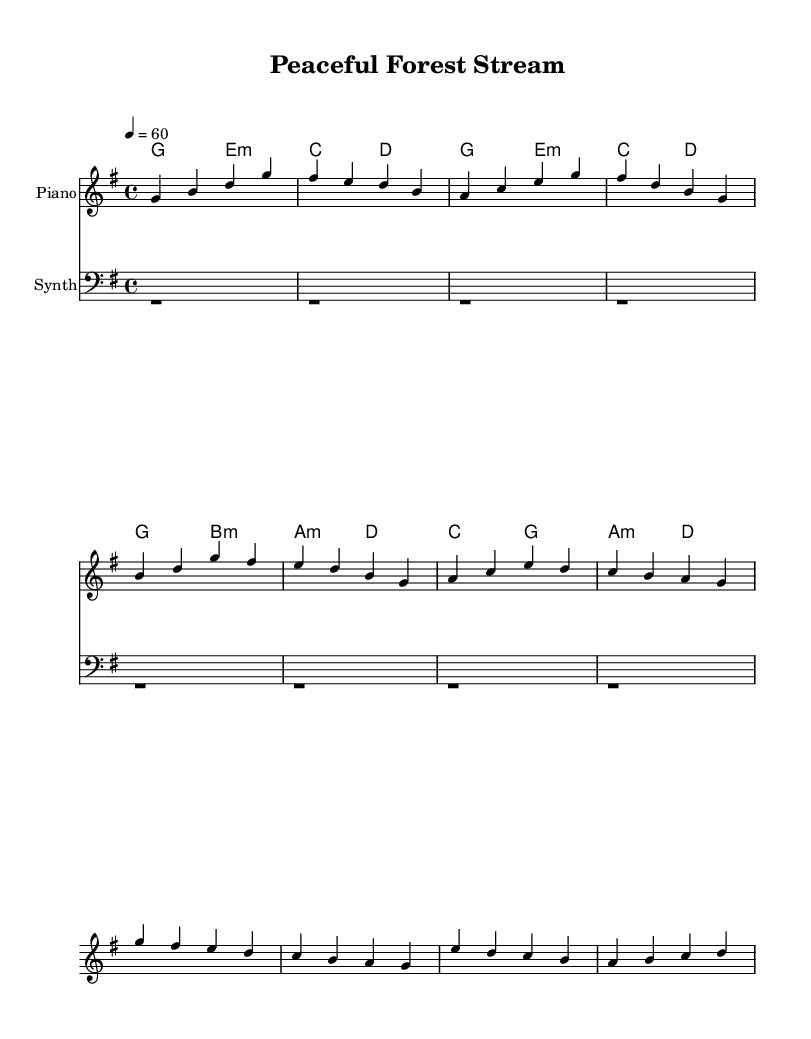What is the key signature of this music? The key signature indicated in the sheet music is G major, which has one sharp (F#). This can be identified by looking at the key signature notation at the beginning of the staff.
Answer: G major What is the time signature of this music? The time signature is 4/4, which is shown at the beginning of the score. This means there are four beats in each measure, and each quarter note is one beat.
Answer: 4/4 What is the tempo of this music? The tempo marking indicates a tempo of 60 beats per minute. This is specified at the start of the piece with the marking "4 = 60".
Answer: 60 How many measures are in the melody? By counting the measures in the provided melody sections (Intro, Verse, and Chorus), we find a total of 12 measures. Each line typically contains 4 measures, and there are 3 lines in total for the melody.
Answer: 12 What type of instruments are used in this arrangement? The arrangement includes a Piano and a Synth as indicated in the staff names. Each instrument is represented by its own staff, showing the separate roles they play in the piece.
Answer: Piano and Synth What is the structure of the melody in terms of sections? The melody consists of three sections: Intro, Verse, and Chorus. This can be determined by the labels used in the music and the different melodic lines provided.
Answer: Intro, Verse, Chorus What is the main harmonic progression used in this music? The harmonic progression consists mainly of the chords G, E minor, C, D, B minor, A minor, and back to D as shown in the chord mode section. This pattern creates a soothing backdrop that complements the melody effectively.
Answer: G, E minor, C, D, B minor, A minor, D 